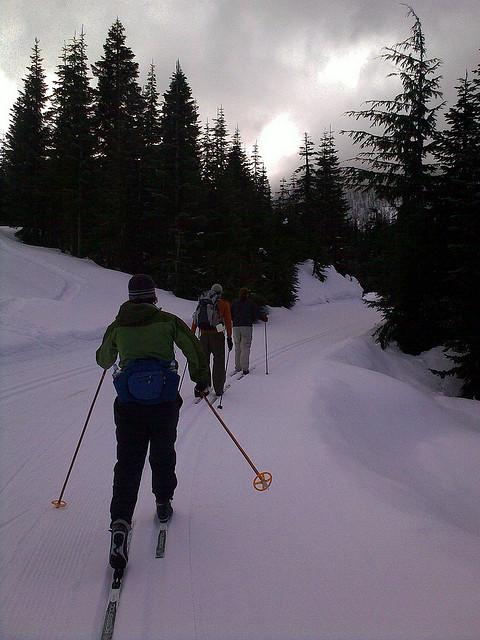Are the people in water?
Concise answer only. No. Is the last person wearing a fanny pack?
Concise answer only. Yes. Are the people currently skiing?
Keep it brief. Yes. Is the skier going down a hill?
Quick response, please. No. Are there footprints in the snow?
Write a very short answer. No. What is one reason it is wise to practice this activity in groups?
Short answer required. Safety. Why is the man wearing sunglasses when it is winter out?
Quick response, please. Protection. 